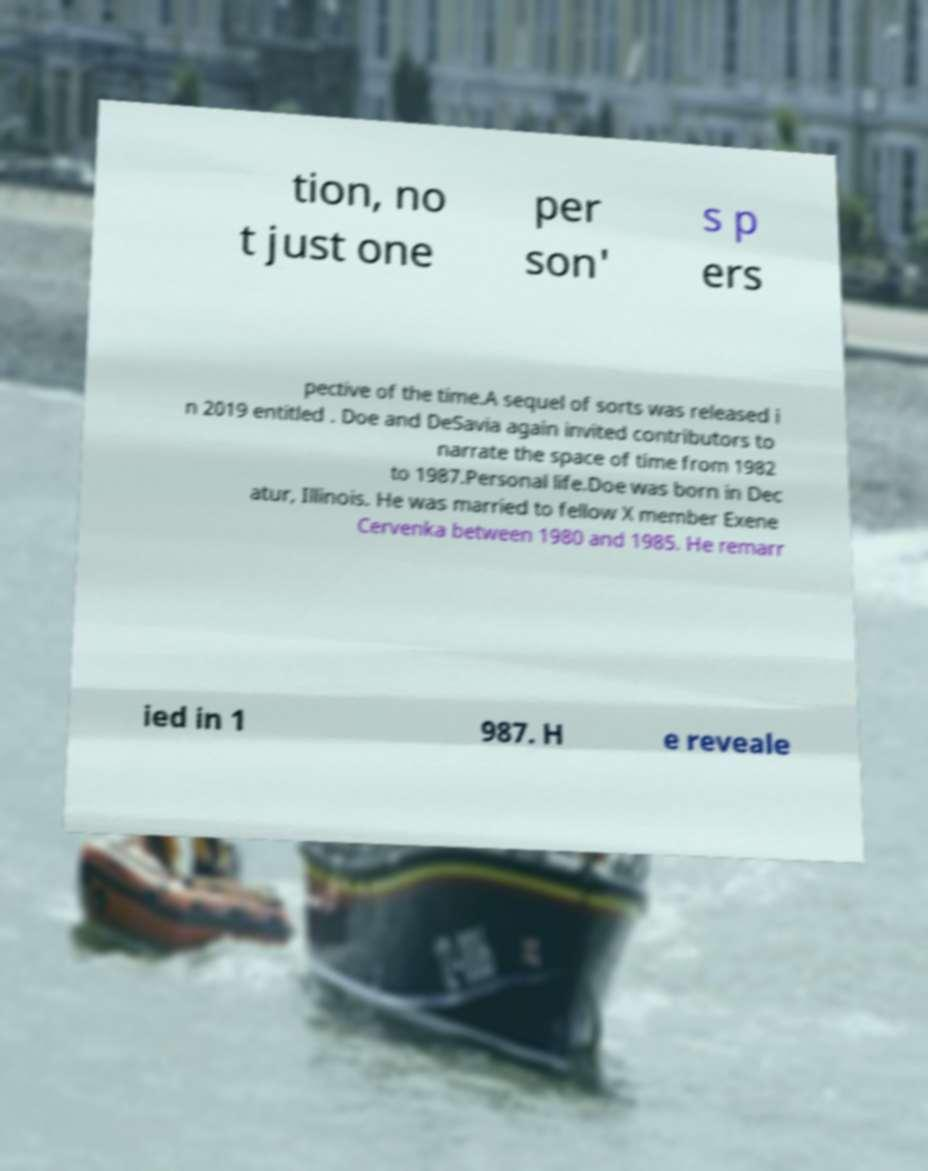Could you extract and type out the text from this image? tion, no t just one per son' s p ers pective of the time.A sequel of sorts was released i n 2019 entitled . Doe and DeSavia again invited contributors to narrate the space of time from 1982 to 1987.Personal life.Doe was born in Dec atur, Illinois. He was married to fellow X member Exene Cervenka between 1980 and 1985. He remarr ied in 1 987. H e reveale 